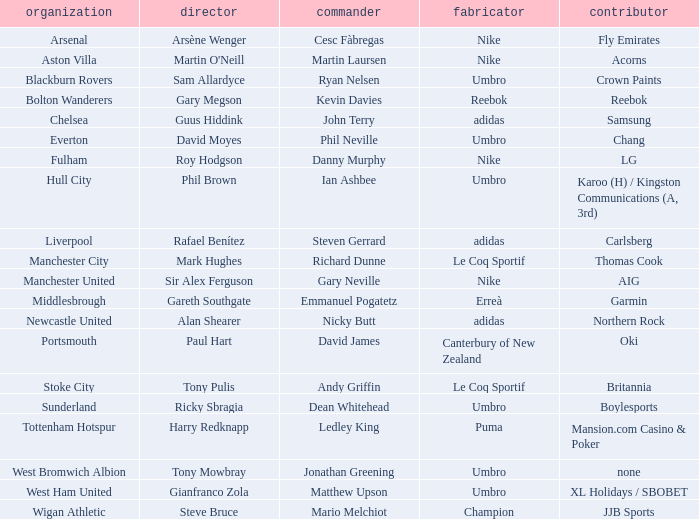Which Manchester United captain is sponsored by Nike? Gary Neville. 